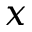Convert formula to latex. <formula><loc_0><loc_0><loc_500><loc_500>x</formula> 